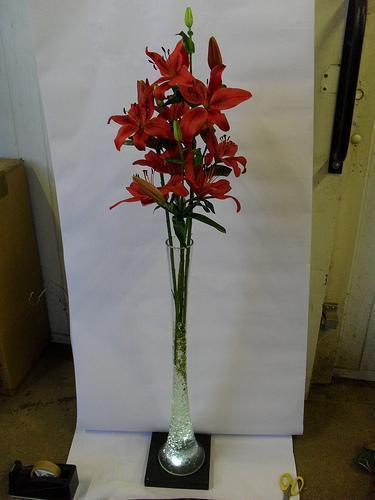How many vases are in the picture?
Give a very brief answer. 1. 